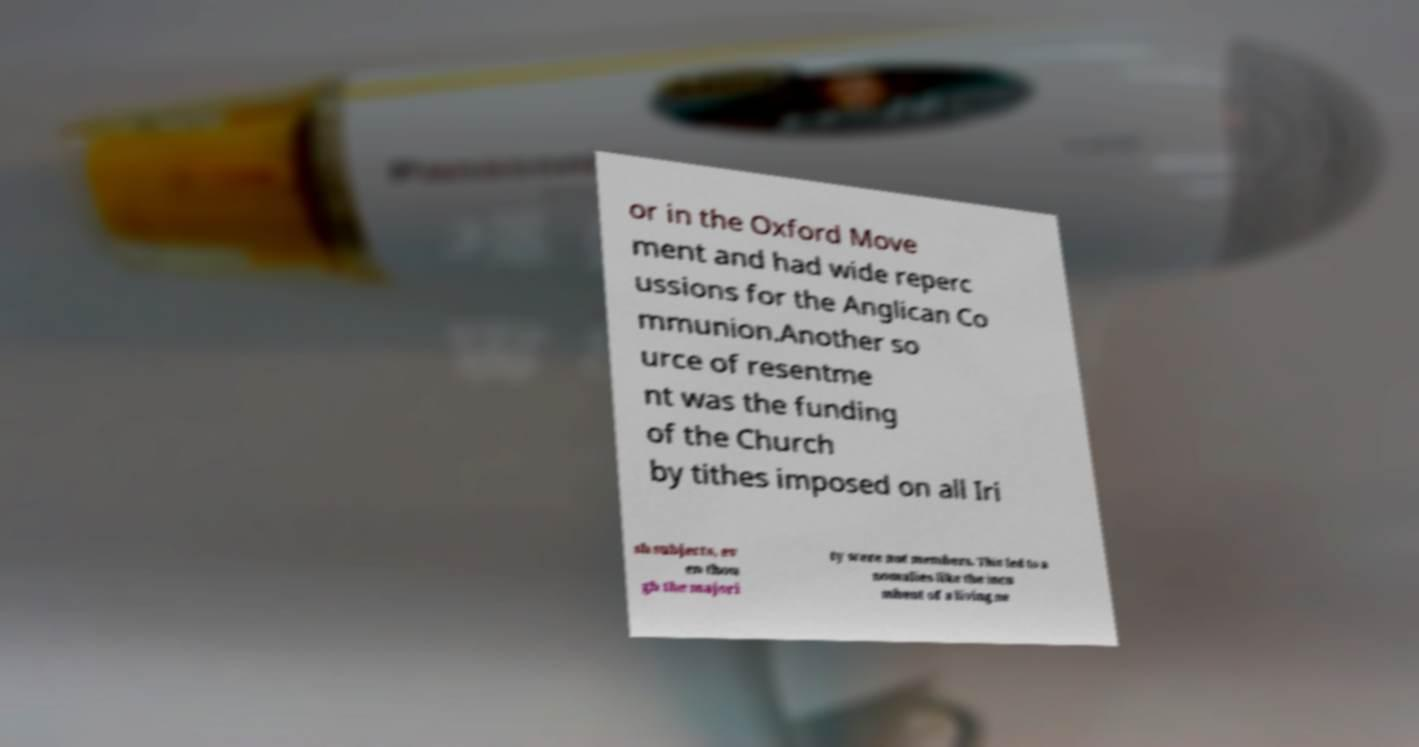Can you read and provide the text displayed in the image?This photo seems to have some interesting text. Can you extract and type it out for me? or in the Oxford Move ment and had wide reperc ussions for the Anglican Co mmunion.Another so urce of resentme nt was the funding of the Church by tithes imposed on all Iri sh subjects, ev en thou gh the majori ty were not members. This led to a nomalies like the incu mbent of a living ne 